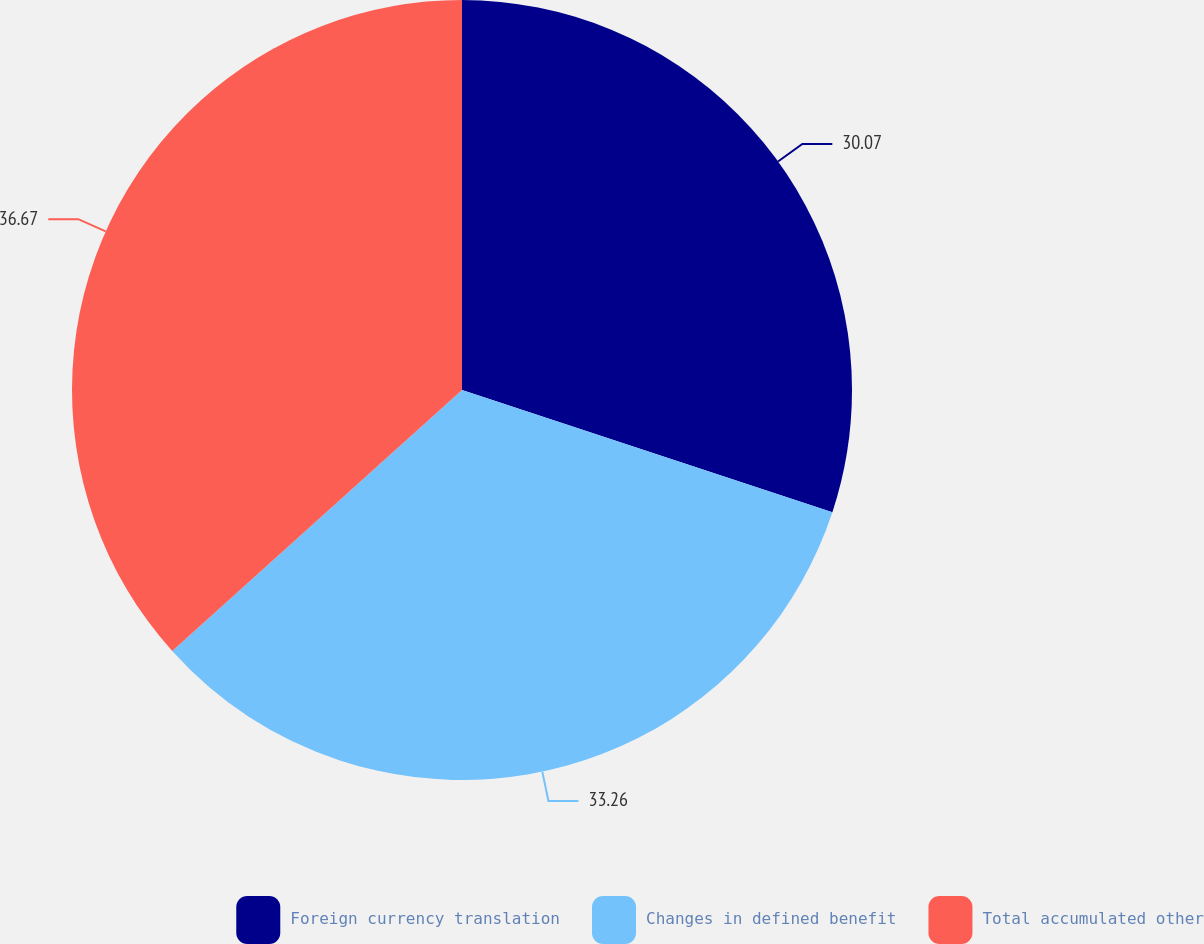Convert chart to OTSL. <chart><loc_0><loc_0><loc_500><loc_500><pie_chart><fcel>Foreign currency translation<fcel>Changes in defined benefit<fcel>Total accumulated other<nl><fcel>30.07%<fcel>33.26%<fcel>36.67%<nl></chart> 